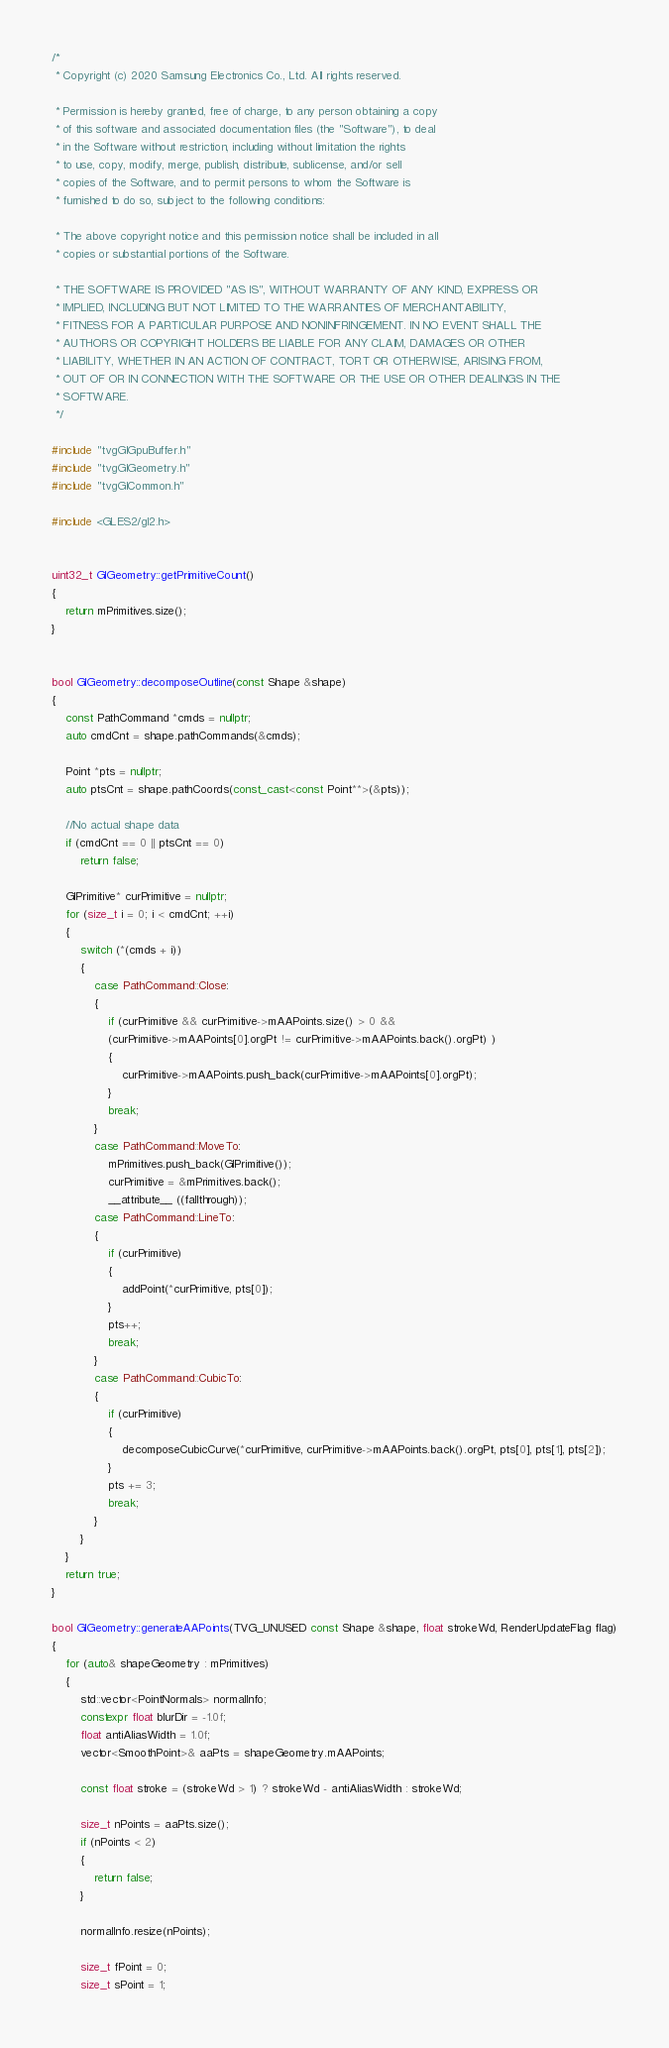Convert code to text. <code><loc_0><loc_0><loc_500><loc_500><_C++_>/*
 * Copyright (c) 2020 Samsung Electronics Co., Ltd. All rights reserved.

 * Permission is hereby granted, free of charge, to any person obtaining a copy
 * of this software and associated documentation files (the "Software"), to deal
 * in the Software without restriction, including without limitation the rights
 * to use, copy, modify, merge, publish, distribute, sublicense, and/or sell
 * copies of the Software, and to permit persons to whom the Software is
 * furnished to do so, subject to the following conditions:

 * The above copyright notice and this permission notice shall be included in all
 * copies or substantial portions of the Software.

 * THE SOFTWARE IS PROVIDED "AS IS", WITHOUT WARRANTY OF ANY KIND, EXPRESS OR
 * IMPLIED, INCLUDING BUT NOT LIMITED TO THE WARRANTIES OF MERCHANTABILITY,
 * FITNESS FOR A PARTICULAR PURPOSE AND NONINFRINGEMENT. IN NO EVENT SHALL THE
 * AUTHORS OR COPYRIGHT HOLDERS BE LIABLE FOR ANY CLAIM, DAMAGES OR OTHER
 * LIABILITY, WHETHER IN AN ACTION OF CONTRACT, TORT OR OTHERWISE, ARISING FROM,
 * OUT OF OR IN CONNECTION WITH THE SOFTWARE OR THE USE OR OTHER DEALINGS IN THE
 * SOFTWARE.
 */

#include "tvgGlGpuBuffer.h"
#include "tvgGlGeometry.h"
#include "tvgGlCommon.h"

#include <GLES2/gl2.h>


uint32_t GlGeometry::getPrimitiveCount()
{
    return mPrimitives.size();
}


bool GlGeometry::decomposeOutline(const Shape &shape)
{
    const PathCommand *cmds = nullptr;
    auto cmdCnt = shape.pathCommands(&cmds);

    Point *pts = nullptr;
    auto ptsCnt = shape.pathCoords(const_cast<const Point**>(&pts));

    //No actual shape data
    if (cmdCnt == 0 || ptsCnt == 0)
        return false;

    GlPrimitive* curPrimitive = nullptr;
    for (size_t i = 0; i < cmdCnt; ++i)
    {
        switch (*(cmds + i))
        {
            case PathCommand::Close:
            {
                if (curPrimitive && curPrimitive->mAAPoints.size() > 0 &&
                (curPrimitive->mAAPoints[0].orgPt != curPrimitive->mAAPoints.back().orgPt) )
                {
                    curPrimitive->mAAPoints.push_back(curPrimitive->mAAPoints[0].orgPt);
                }
                break;
            }
            case PathCommand::MoveTo:
                mPrimitives.push_back(GlPrimitive());
                curPrimitive = &mPrimitives.back();
                __attribute__ ((fallthrough));
            case PathCommand::LineTo:
            {
                if (curPrimitive)
                {
                    addPoint(*curPrimitive, pts[0]);
                }
                pts++;
                break;
            }
            case PathCommand::CubicTo:
            {
                if (curPrimitive)
                {
                    decomposeCubicCurve(*curPrimitive, curPrimitive->mAAPoints.back().orgPt, pts[0], pts[1], pts[2]);
                }
                pts += 3;
                break;
            }
        }
    }
    return true;
}

bool GlGeometry::generateAAPoints(TVG_UNUSED const Shape &shape, float strokeWd, RenderUpdateFlag flag)
{
    for (auto& shapeGeometry : mPrimitives)
    {
        std::vector<PointNormals> normalInfo;
        constexpr float blurDir = -1.0f;
        float antiAliasWidth = 1.0f;
        vector<SmoothPoint>& aaPts = shapeGeometry.mAAPoints;

        const float stroke = (strokeWd > 1) ? strokeWd - antiAliasWidth : strokeWd;

        size_t nPoints = aaPts.size();
        if (nPoints < 2)
        {
            return false;
        }

        normalInfo.resize(nPoints);

        size_t fPoint = 0;
        size_t sPoint = 1;</code> 